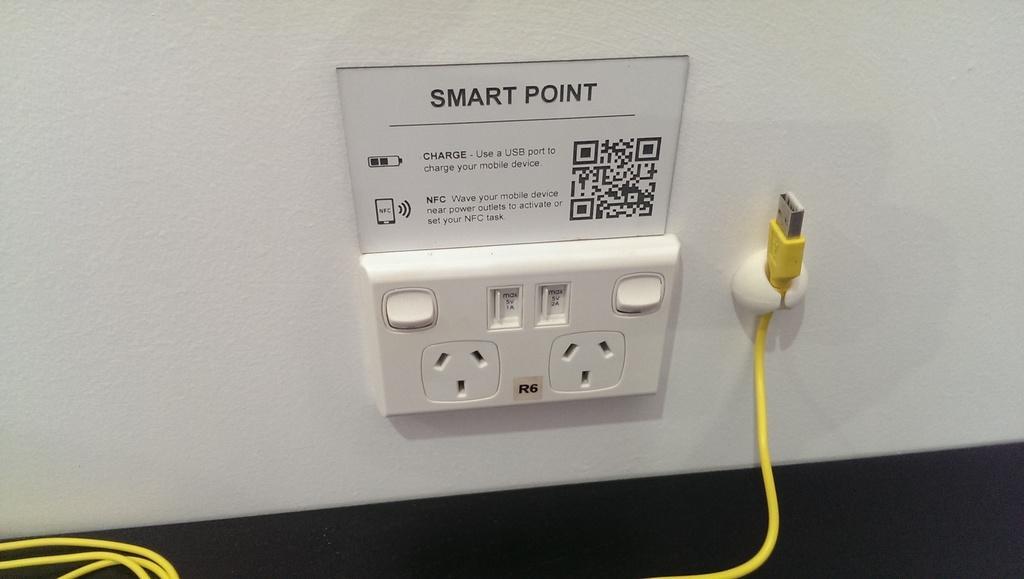Describe this image in one or two sentences. In the picture we can see a switch board to the wall and beside it we can see a charger wire which is yellow in color and on the switch board we can see some note. 